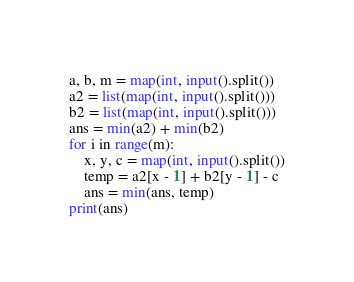Convert code to text. <code><loc_0><loc_0><loc_500><loc_500><_Python_>a, b, m = map(int, input().split())
a2 = list(map(int, input().split()))
b2 = list(map(int, input().split()))
ans = min(a2) + min(b2)
for i in range(m):
    x, y, c = map(int, input().split())
    temp = a2[x - 1] + b2[y - 1] - c
    ans = min(ans, temp)
print(ans)</code> 